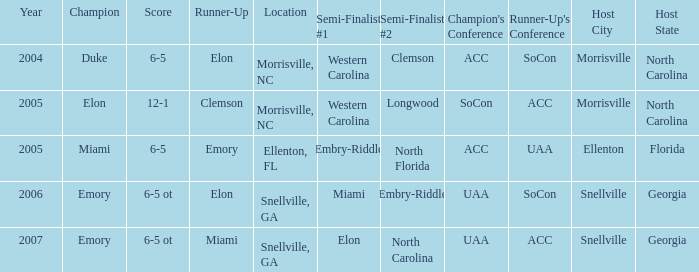Where was the final game played in 2007 Snellville, GA. 